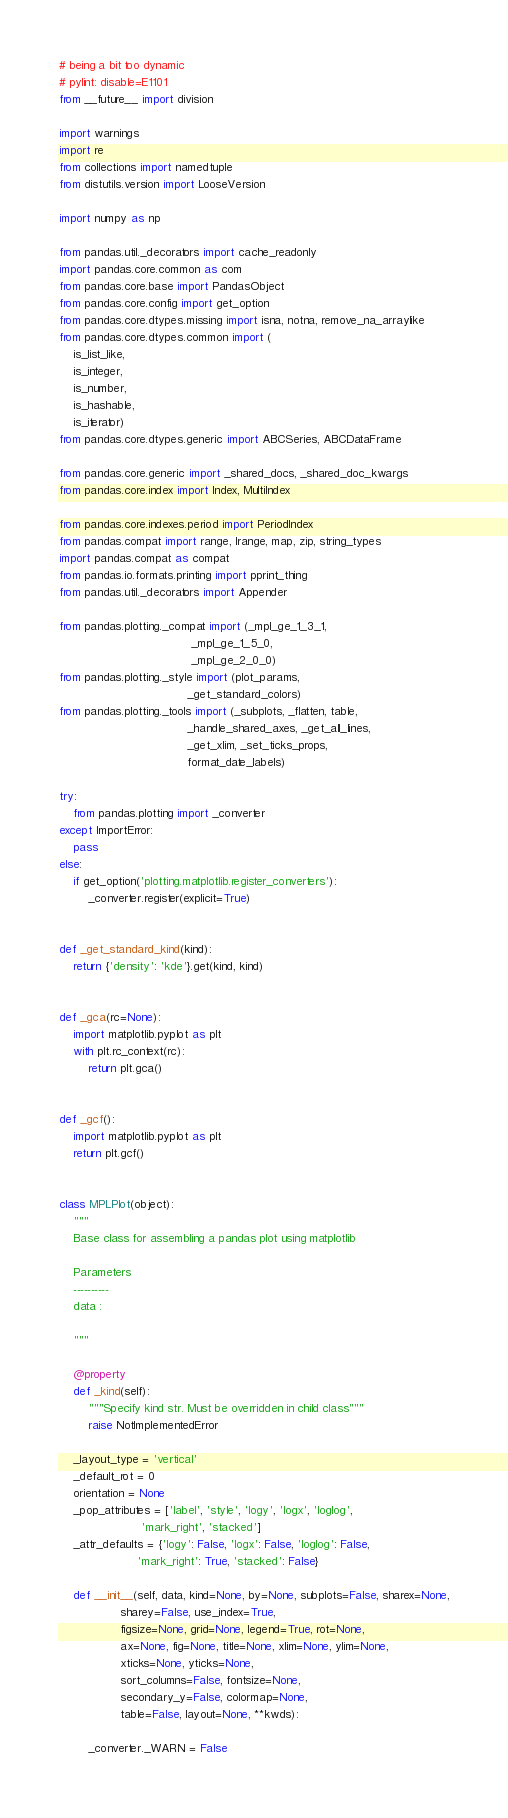<code> <loc_0><loc_0><loc_500><loc_500><_Python_># being a bit too dynamic
# pylint: disable=E1101
from __future__ import division

import warnings
import re
from collections import namedtuple
from distutils.version import LooseVersion

import numpy as np

from pandas.util._decorators import cache_readonly
import pandas.core.common as com
from pandas.core.base import PandasObject
from pandas.core.config import get_option
from pandas.core.dtypes.missing import isna, notna, remove_na_arraylike
from pandas.core.dtypes.common import (
    is_list_like,
    is_integer,
    is_number,
    is_hashable,
    is_iterator)
from pandas.core.dtypes.generic import ABCSeries, ABCDataFrame

from pandas.core.generic import _shared_docs, _shared_doc_kwargs
from pandas.core.index import Index, MultiIndex

from pandas.core.indexes.period import PeriodIndex
from pandas.compat import range, lrange, map, zip, string_types
import pandas.compat as compat
from pandas.io.formats.printing import pprint_thing
from pandas.util._decorators import Appender

from pandas.plotting._compat import (_mpl_ge_1_3_1,
                                     _mpl_ge_1_5_0,
                                     _mpl_ge_2_0_0)
from pandas.plotting._style import (plot_params,
                                    _get_standard_colors)
from pandas.plotting._tools import (_subplots, _flatten, table,
                                    _handle_shared_axes, _get_all_lines,
                                    _get_xlim, _set_ticks_props,
                                    format_date_labels)

try:
    from pandas.plotting import _converter
except ImportError:
    pass
else:
    if get_option('plotting.matplotlib.register_converters'):
        _converter.register(explicit=True)


def _get_standard_kind(kind):
    return {'density': 'kde'}.get(kind, kind)


def _gca(rc=None):
    import matplotlib.pyplot as plt
    with plt.rc_context(rc):
        return plt.gca()


def _gcf():
    import matplotlib.pyplot as plt
    return plt.gcf()


class MPLPlot(object):
    """
    Base class for assembling a pandas plot using matplotlib

    Parameters
    ----------
    data :

    """

    @property
    def _kind(self):
        """Specify kind str. Must be overridden in child class"""
        raise NotImplementedError

    _layout_type = 'vertical'
    _default_rot = 0
    orientation = None
    _pop_attributes = ['label', 'style', 'logy', 'logx', 'loglog',
                       'mark_right', 'stacked']
    _attr_defaults = {'logy': False, 'logx': False, 'loglog': False,
                      'mark_right': True, 'stacked': False}

    def __init__(self, data, kind=None, by=None, subplots=False, sharex=None,
                 sharey=False, use_index=True,
                 figsize=None, grid=None, legend=True, rot=None,
                 ax=None, fig=None, title=None, xlim=None, ylim=None,
                 xticks=None, yticks=None,
                 sort_columns=False, fontsize=None,
                 secondary_y=False, colormap=None,
                 table=False, layout=None, **kwds):

        _converter._WARN = False</code> 